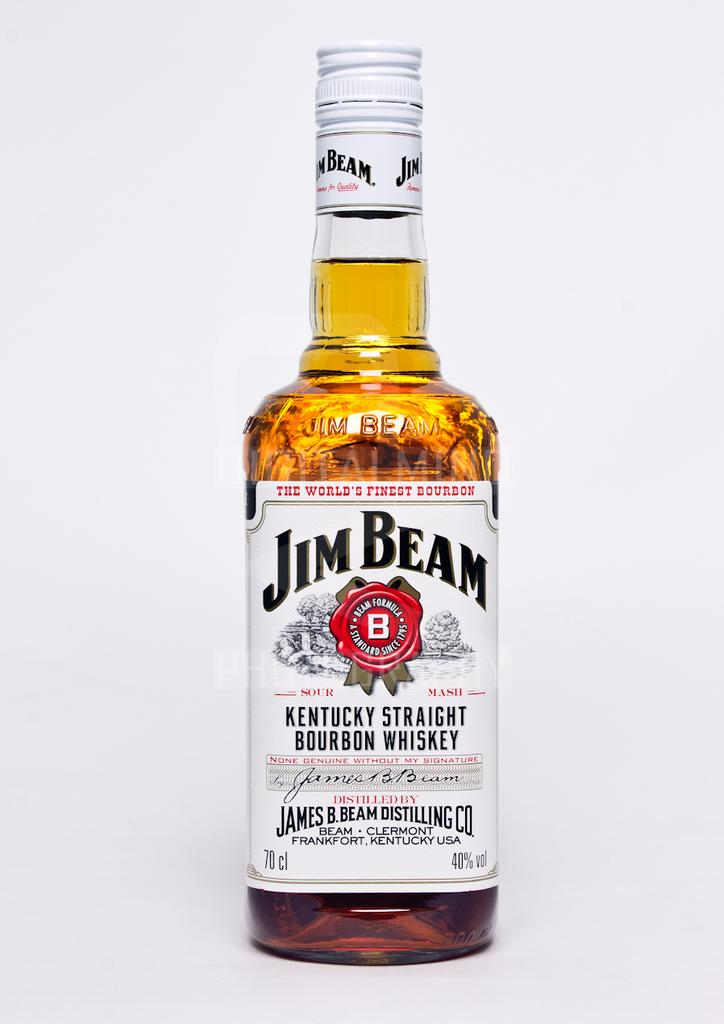<image>
Summarize the visual content of the image. A full bottle of Jim Beam Kentucky straight bourbon whiskey 